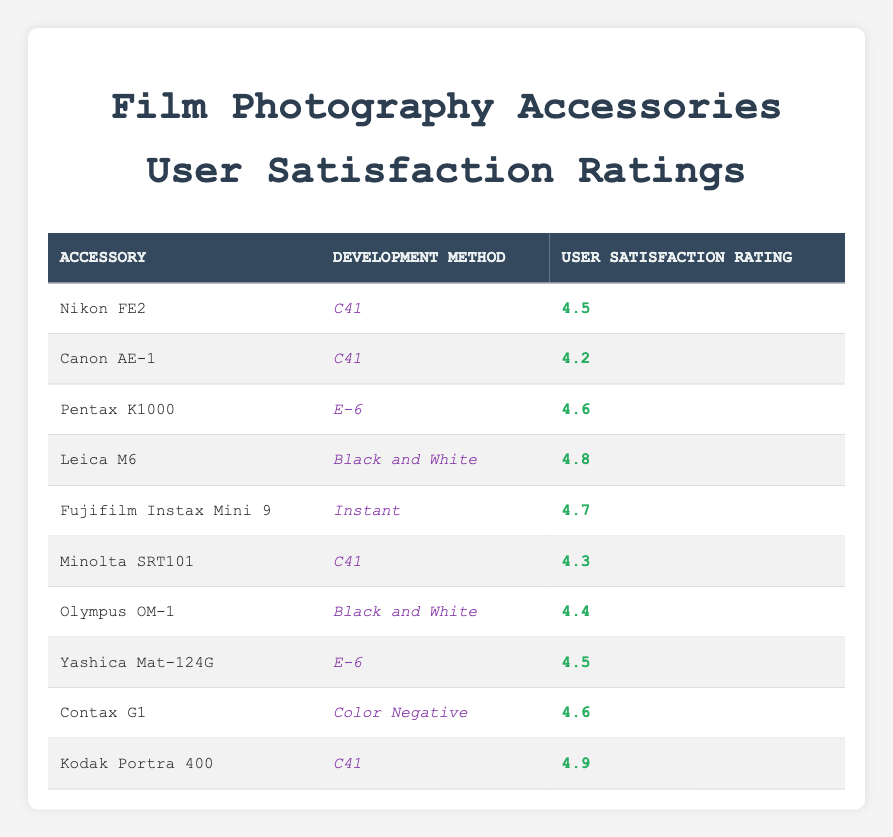What is the user satisfaction rating for the Nikon FE2 using the C41 development method? The table lists the user satisfaction rating for the Nikon FE2 in the row corresponding to the C41 development method, which is shown as 4.5.
Answer: 4.5 Which accessory has the highest user satisfaction rating in the Black and White development method? From the table, the user satisfaction ratings for Black and White development method are 4.8 for the Leica M6 and 4.4 for the Olympus OM-1. Since 4.8 is higher than 4.4, the Leica M6 has the highest rating.
Answer: Leica M6 What is the average user satisfaction rating for accessories using the C41 development method? The C41 development method ratings are 4.5 (Nikon FE2), 4.2 (Canon AE-1), 4.3 (Minolta SRT101), and 4.9 (Kodak Portra 400). Adding these gives 4.5 + 4.2 + 4.3 + 4.9 = 17.9. There are four accessories, so the average is 17.9 / 4 = 4.475.
Answer: 4.475 Is the user satisfaction rating for the Fujifilm Instax Mini 9 higher than 4.5? The Fujifilm Instax Mini 9 has a user satisfaction rating of 4.7, which is indeed higher than 4.5.
Answer: Yes How many accessories have a user satisfaction rating of 4.6 or higher? The ratings equal to or higher than 4.6 are associated with accessories: Pentax K1000 (4.6), Fujifilm Instax Mini 9 (4.7), Leica M6 (4.8), Kodak Portra 400 (4.9), and two more with 4.6 (Contax G1 & Yashica Mat-124G). This makes a total of 6 accessories.
Answer: 6 Which development method has the lowest user satisfaction rating? The lowest rating from the development methods presented in the table corresponds to Canon AE-1 under the C41 method with a user satisfaction rating of 4.2.
Answer: C41 What is the difference in user satisfaction ratings between the best and worst-rated accessories in the E-6 method? The E-6 method ratings are 4.6 for Pentax K1000 and 4.5 for Yashica Mat-124G. The difference between them is 4.6 - 4.5 = 0.1.
Answer: 0.1 Are there any accessories rated exactly 4.5? According to the table, the accessories that have a rating of 4.5 are Nikon FE2 (C41) and Yashica Mat-124G (E-6). Therefore, there are accessories rated exactly 4.5.
Answer: Yes 